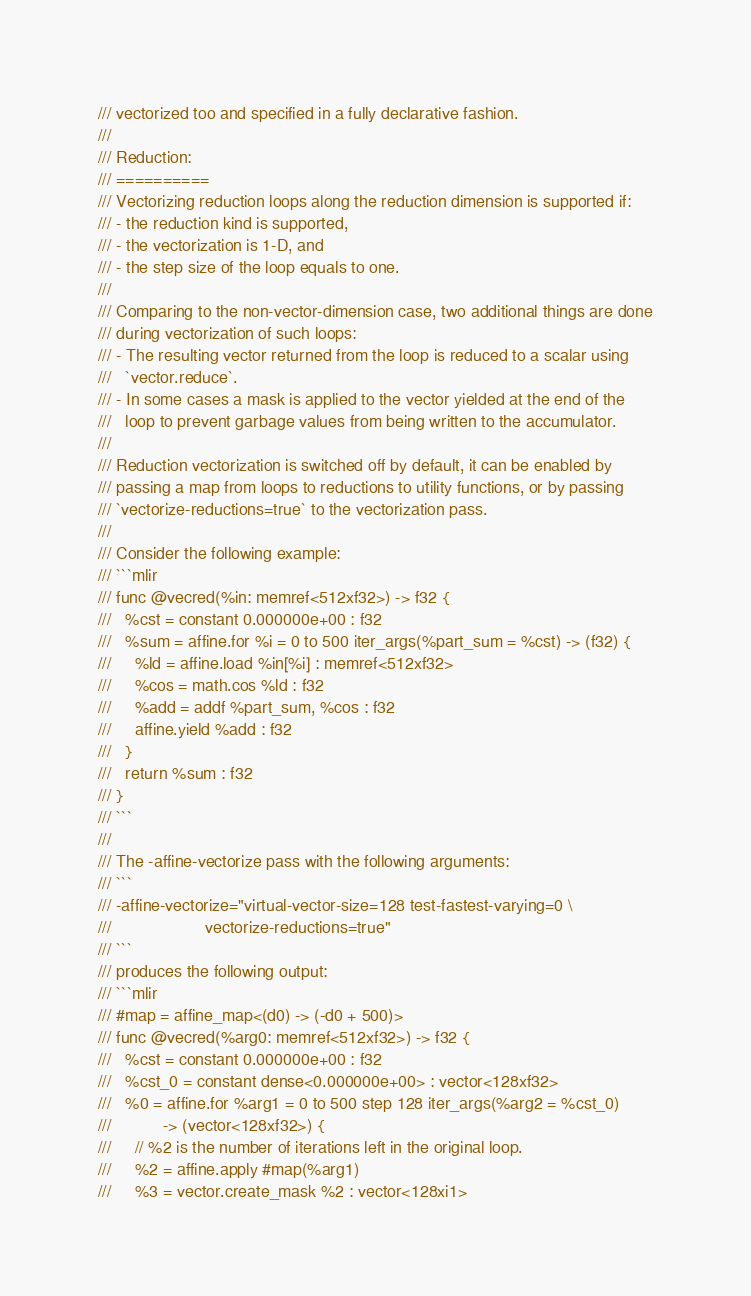<code> <loc_0><loc_0><loc_500><loc_500><_C++_>/// vectorized too and specified in a fully declarative fashion.
///
/// Reduction:
/// ==========
/// Vectorizing reduction loops along the reduction dimension is supported if:
/// - the reduction kind is supported,
/// - the vectorization is 1-D, and
/// - the step size of the loop equals to one.
///
/// Comparing to the non-vector-dimension case, two additional things are done
/// during vectorization of such loops:
/// - The resulting vector returned from the loop is reduced to a scalar using
///   `vector.reduce`.
/// - In some cases a mask is applied to the vector yielded at the end of the
///   loop to prevent garbage values from being written to the accumulator.
///
/// Reduction vectorization is switched off by default, it can be enabled by
/// passing a map from loops to reductions to utility functions, or by passing
/// `vectorize-reductions=true` to the vectorization pass.
///
/// Consider the following example:
/// ```mlir
/// func @vecred(%in: memref<512xf32>) -> f32 {
///   %cst = constant 0.000000e+00 : f32
///   %sum = affine.for %i = 0 to 500 iter_args(%part_sum = %cst) -> (f32) {
///     %ld = affine.load %in[%i] : memref<512xf32>
///     %cos = math.cos %ld : f32
///     %add = addf %part_sum, %cos : f32
///     affine.yield %add : f32
///   }
///   return %sum : f32
/// }
/// ```
///
/// The -affine-vectorize pass with the following arguments:
/// ```
/// -affine-vectorize="virtual-vector-size=128 test-fastest-varying=0 \
///                    vectorize-reductions=true"
/// ```
/// produces the following output:
/// ```mlir
/// #map = affine_map<(d0) -> (-d0 + 500)>
/// func @vecred(%arg0: memref<512xf32>) -> f32 {
///   %cst = constant 0.000000e+00 : f32
///   %cst_0 = constant dense<0.000000e+00> : vector<128xf32>
///   %0 = affine.for %arg1 = 0 to 500 step 128 iter_args(%arg2 = %cst_0)
///           -> (vector<128xf32>) {
///     // %2 is the number of iterations left in the original loop.
///     %2 = affine.apply #map(%arg1)
///     %3 = vector.create_mask %2 : vector<128xi1></code> 